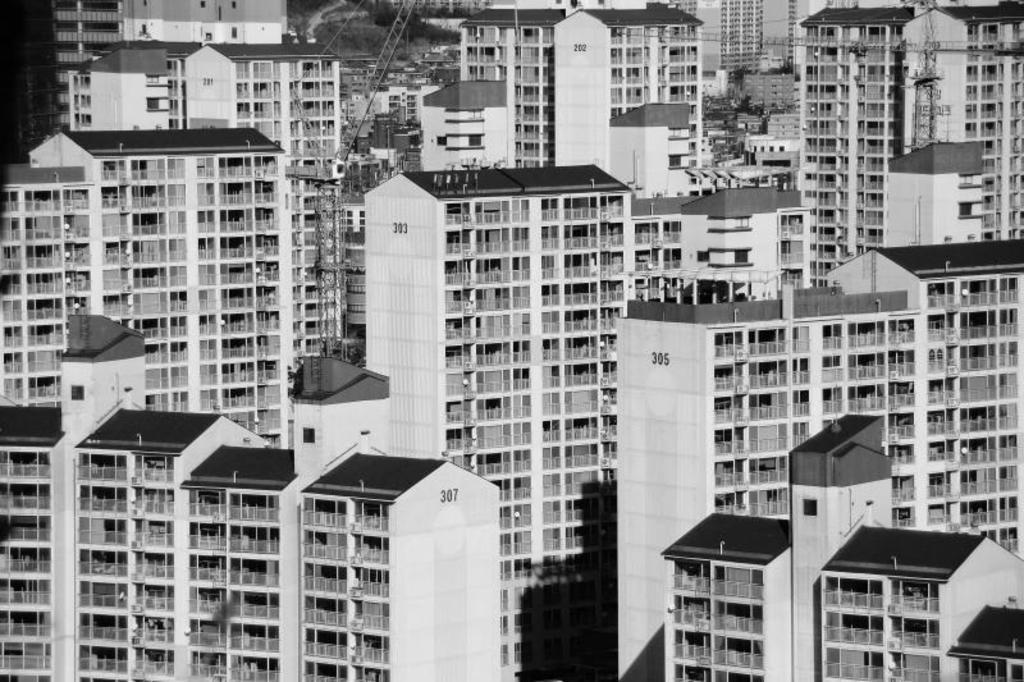What type of buildings can be seen in the image? There are skyscrapers in the image. What kind of environment is depicted in the image? The image appears to depict an urban area. What color is the scarf worn by the person on the railway in the image? There is no railway or person wearing a scarf present in the image. How many quills are visible on the ground in the image? There are no quills visible in the image. 